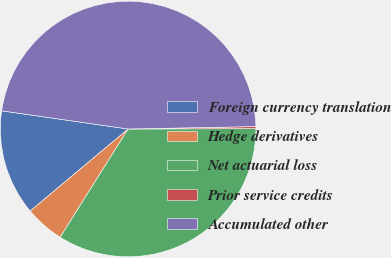Convert chart. <chart><loc_0><loc_0><loc_500><loc_500><pie_chart><fcel>Foreign currency translation<fcel>Hedge derivatives<fcel>Net actuarial loss<fcel>Prior service credits<fcel>Accumulated other<nl><fcel>13.37%<fcel>4.98%<fcel>33.97%<fcel>0.26%<fcel>47.43%<nl></chart> 